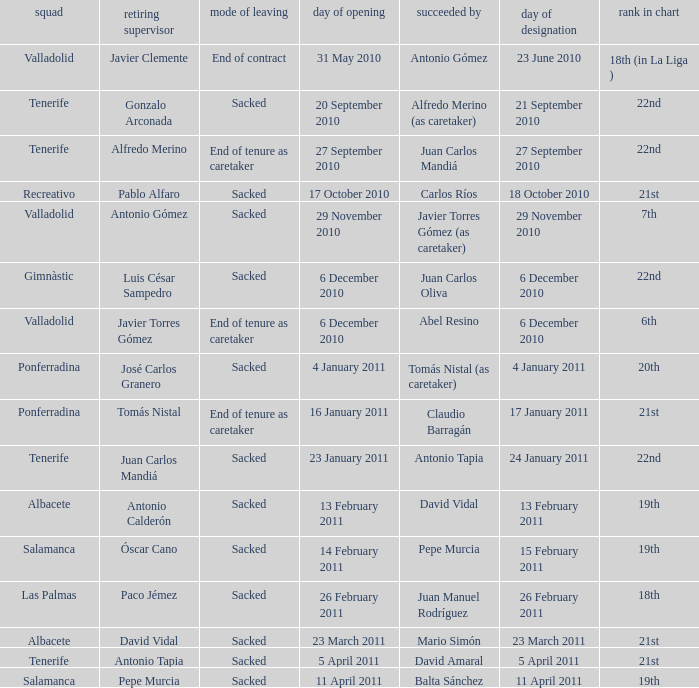What is the position for outgoing manager alfredo merino 22nd. 